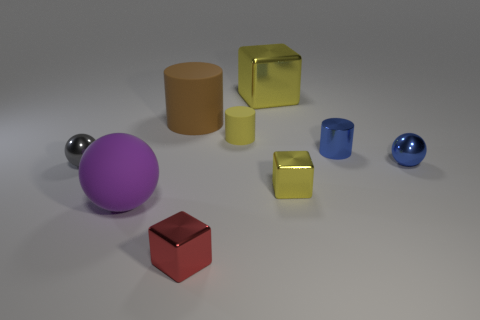Subtract all cylinders. How many objects are left? 6 Add 3 large rubber balls. How many large rubber balls are left? 4 Add 6 tiny yellow metallic cylinders. How many tiny yellow metallic cylinders exist? 6 Subtract 0 brown cubes. How many objects are left? 9 Subtract all tiny gray matte balls. Subtract all yellow rubber things. How many objects are left? 8 